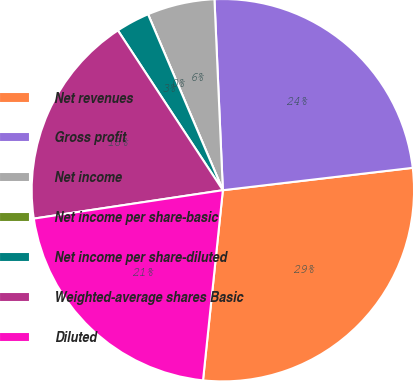<chart> <loc_0><loc_0><loc_500><loc_500><pie_chart><fcel>Net revenues<fcel>Gross profit<fcel>Net income<fcel>Net income per share-basic<fcel>Net income per share-diluted<fcel>Weighted-average shares Basic<fcel>Diluted<nl><fcel>28.52%<fcel>23.83%<fcel>5.7%<fcel>0.0%<fcel>2.85%<fcel>18.12%<fcel>20.97%<nl></chart> 